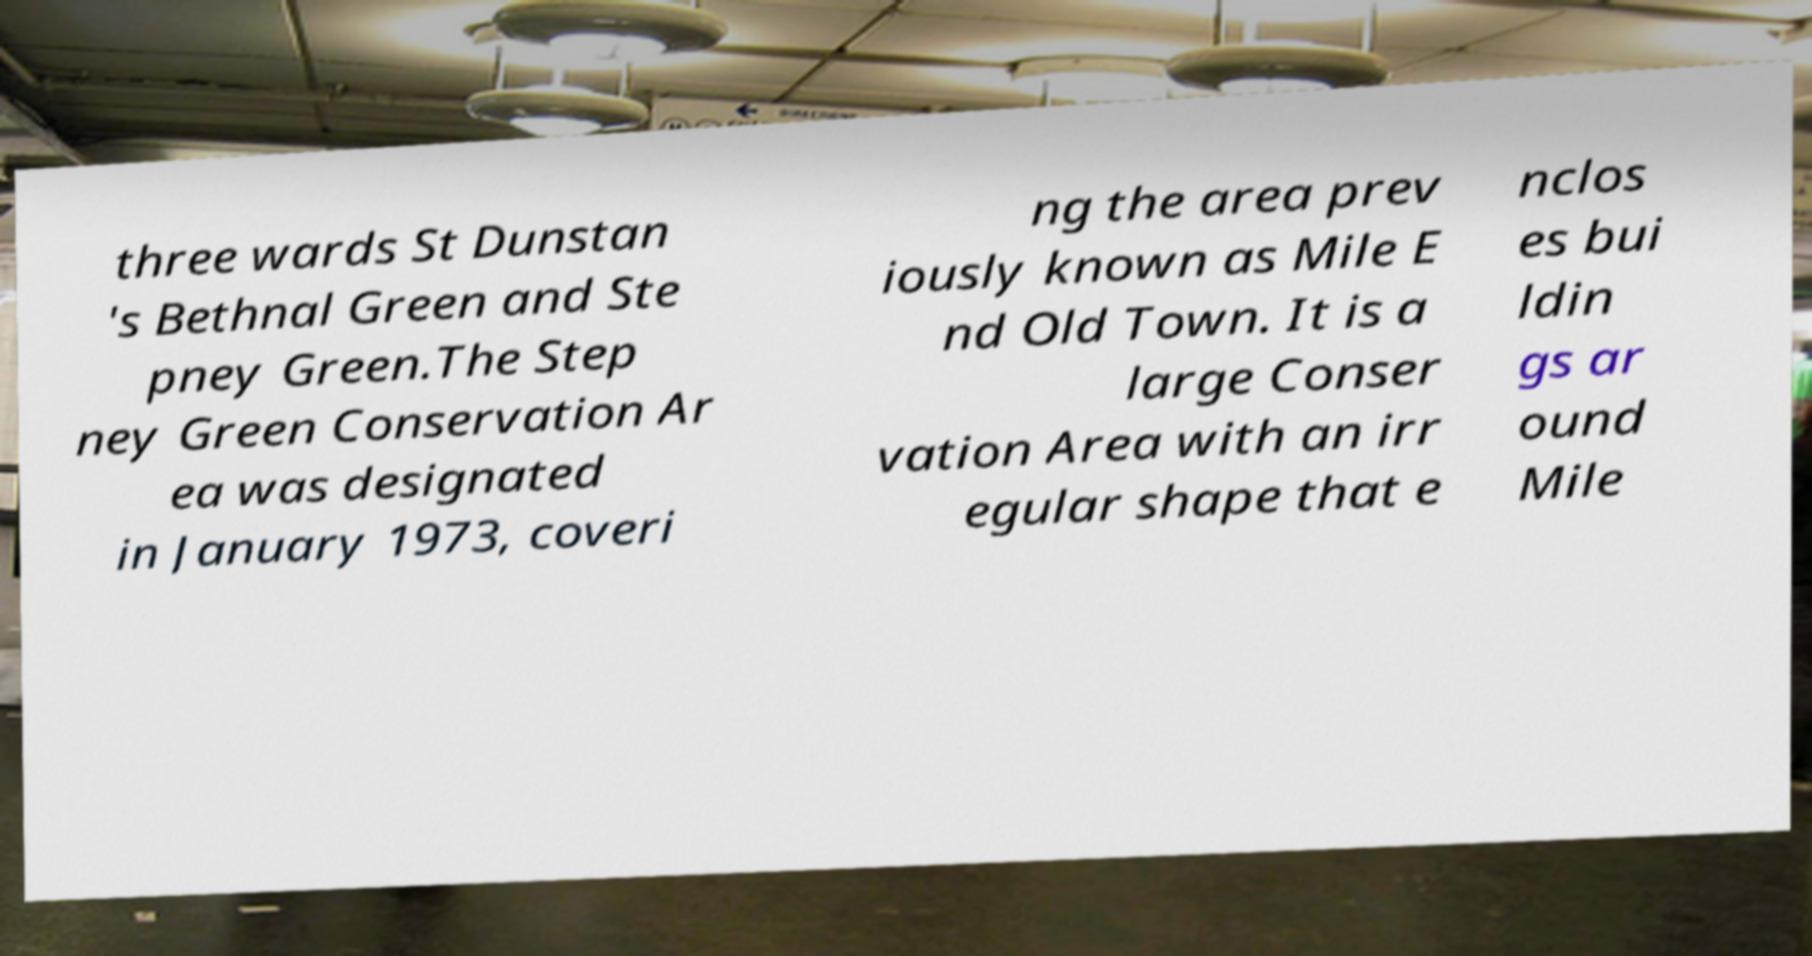Please read and relay the text visible in this image. What does it say? three wards St Dunstan 's Bethnal Green and Ste pney Green.The Step ney Green Conservation Ar ea was designated in January 1973, coveri ng the area prev iously known as Mile E nd Old Town. It is a large Conser vation Area with an irr egular shape that e nclos es bui ldin gs ar ound Mile 